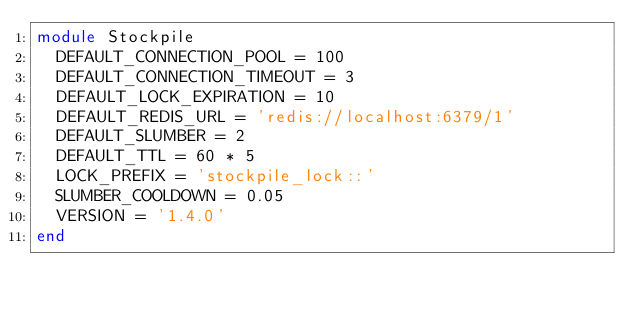Convert code to text. <code><loc_0><loc_0><loc_500><loc_500><_Ruby_>module Stockpile
  DEFAULT_CONNECTION_POOL = 100
  DEFAULT_CONNECTION_TIMEOUT = 3
  DEFAULT_LOCK_EXPIRATION = 10
  DEFAULT_REDIS_URL = 'redis://localhost:6379/1'
  DEFAULT_SLUMBER = 2
  DEFAULT_TTL = 60 * 5
  LOCK_PREFIX = 'stockpile_lock::'
  SLUMBER_COOLDOWN = 0.05
  VERSION = '1.4.0'
end
</code> 